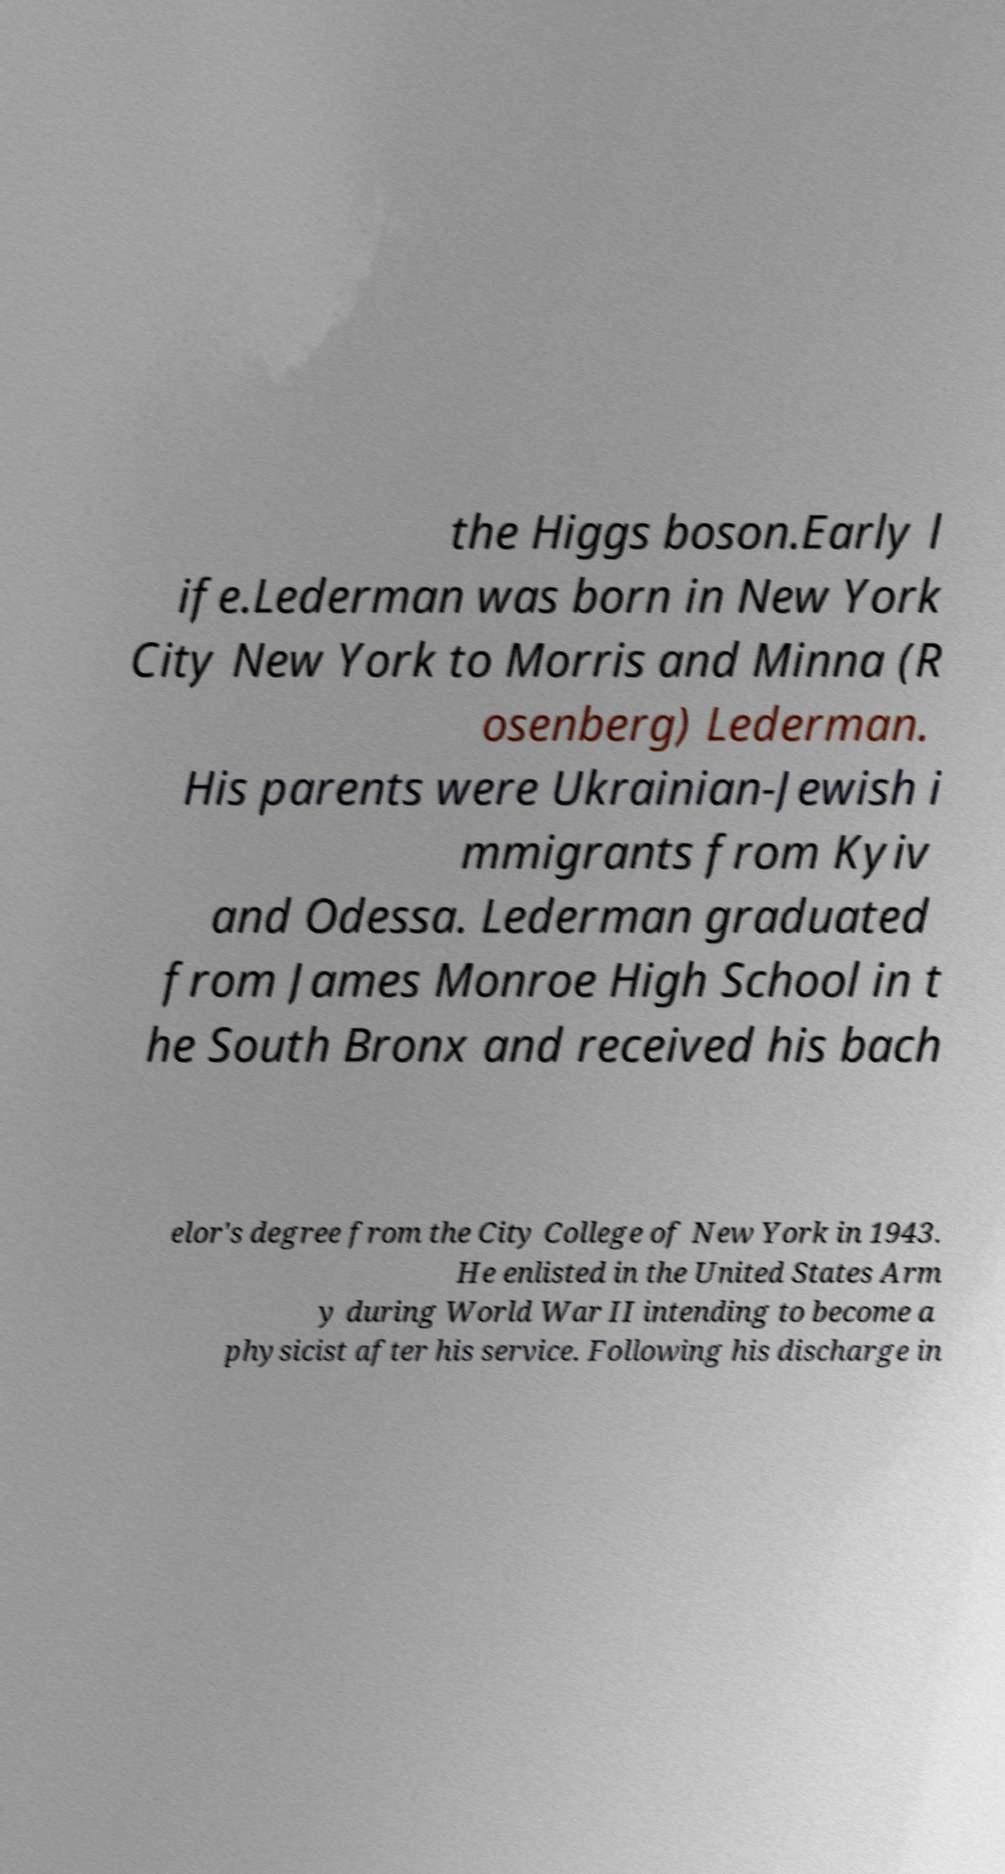There's text embedded in this image that I need extracted. Can you transcribe it verbatim? the Higgs boson.Early l ife.Lederman was born in New York City New York to Morris and Minna (R osenberg) Lederman. His parents were Ukrainian-Jewish i mmigrants from Kyiv and Odessa. Lederman graduated from James Monroe High School in t he South Bronx and received his bach elor's degree from the City College of New York in 1943. He enlisted in the United States Arm y during World War II intending to become a physicist after his service. Following his discharge in 